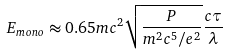Convert formula to latex. <formula><loc_0><loc_0><loc_500><loc_500>E _ { m o n o } \approx 0 . 6 5 m c ^ { 2 } \sqrt { \frac { P } { m ^ { 2 } c ^ { 5 } / e ^ { 2 } } } \frac { c \tau } { \lambda }</formula> 